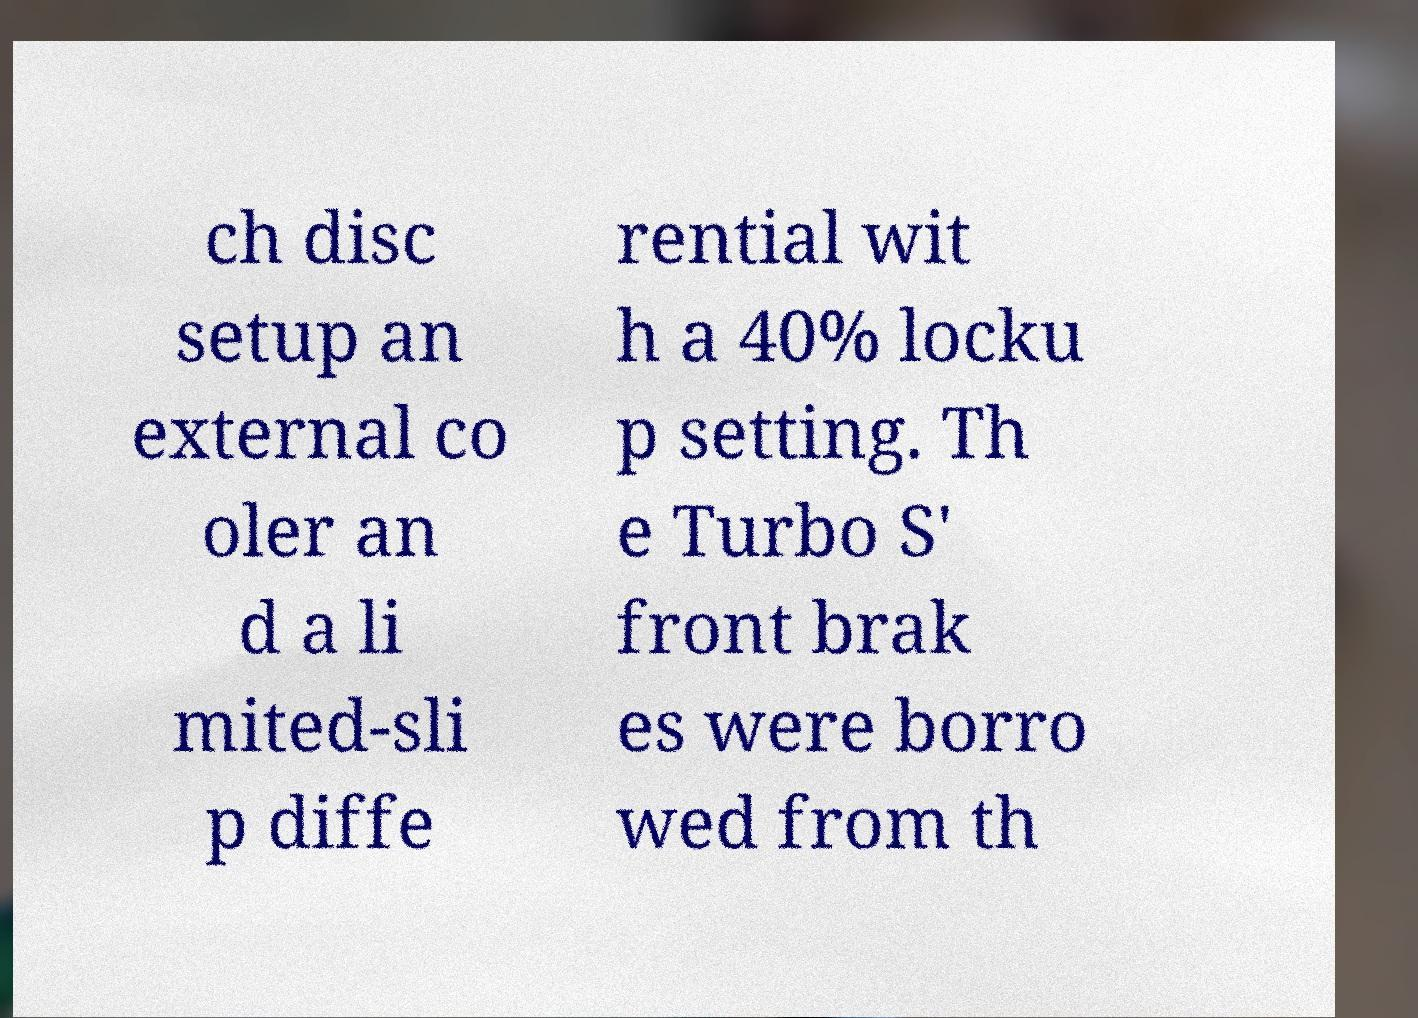Could you assist in decoding the text presented in this image and type it out clearly? ch disc setup an external co oler an d a li mited-sli p diffe rential wit h a 40% locku p setting. Th e Turbo S' front brak es were borro wed from th 